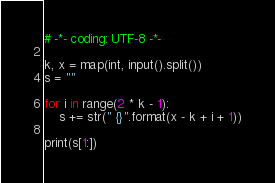Convert code to text. <code><loc_0><loc_0><loc_500><loc_500><_Python_># -*- coding: UTF-8 -*-

k, x = map(int, input().split())
s = ""

for i in range(2 * k - 1):
    s += str(" {}".format(x - k + i + 1))

print(s[1:])
</code> 